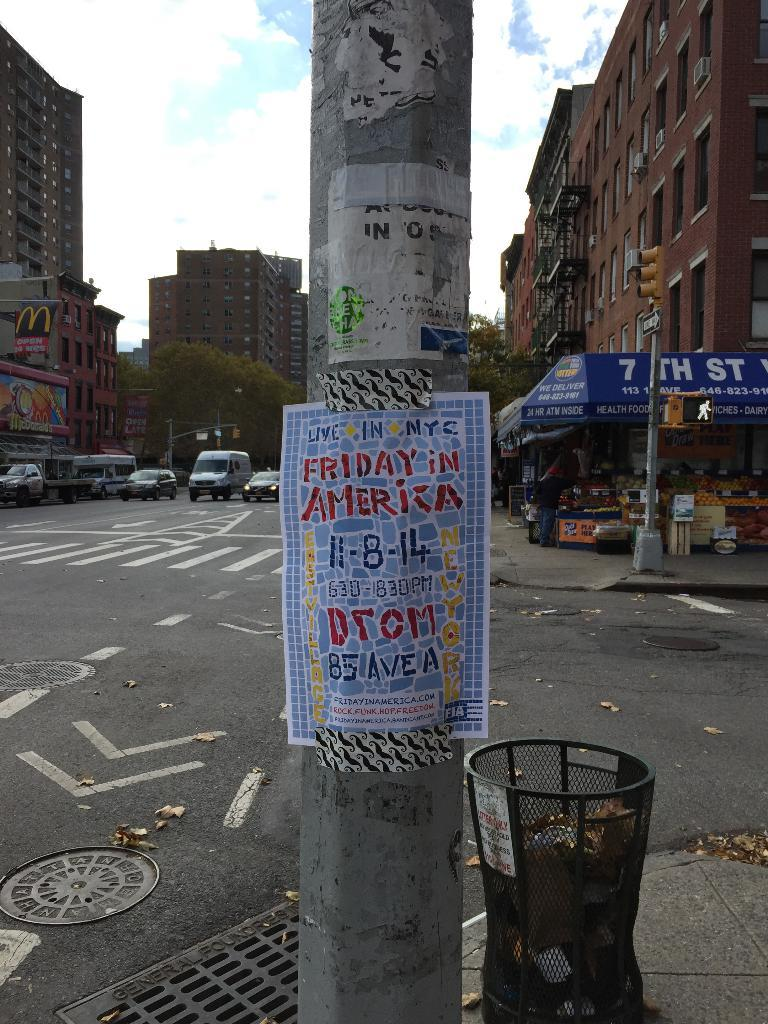Provide a one-sentence caption for the provided image. A poster is taped to a street pole that is advertising Friday in America. 